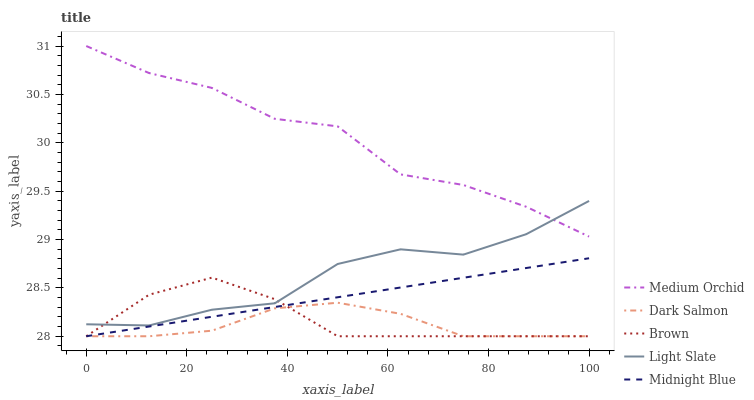Does Dark Salmon have the minimum area under the curve?
Answer yes or no. Yes. Does Medium Orchid have the maximum area under the curve?
Answer yes or no. Yes. Does Brown have the minimum area under the curve?
Answer yes or no. No. Does Brown have the maximum area under the curve?
Answer yes or no. No. Is Midnight Blue the smoothest?
Answer yes or no. Yes. Is Medium Orchid the roughest?
Answer yes or no. Yes. Is Brown the smoothest?
Answer yes or no. No. Is Brown the roughest?
Answer yes or no. No. Does Brown have the lowest value?
Answer yes or no. Yes. Does Medium Orchid have the lowest value?
Answer yes or no. No. Does Medium Orchid have the highest value?
Answer yes or no. Yes. Does Brown have the highest value?
Answer yes or no. No. Is Midnight Blue less than Medium Orchid?
Answer yes or no. Yes. Is Light Slate greater than Dark Salmon?
Answer yes or no. Yes. Does Dark Salmon intersect Midnight Blue?
Answer yes or no. Yes. Is Dark Salmon less than Midnight Blue?
Answer yes or no. No. Is Dark Salmon greater than Midnight Blue?
Answer yes or no. No. Does Midnight Blue intersect Medium Orchid?
Answer yes or no. No. 